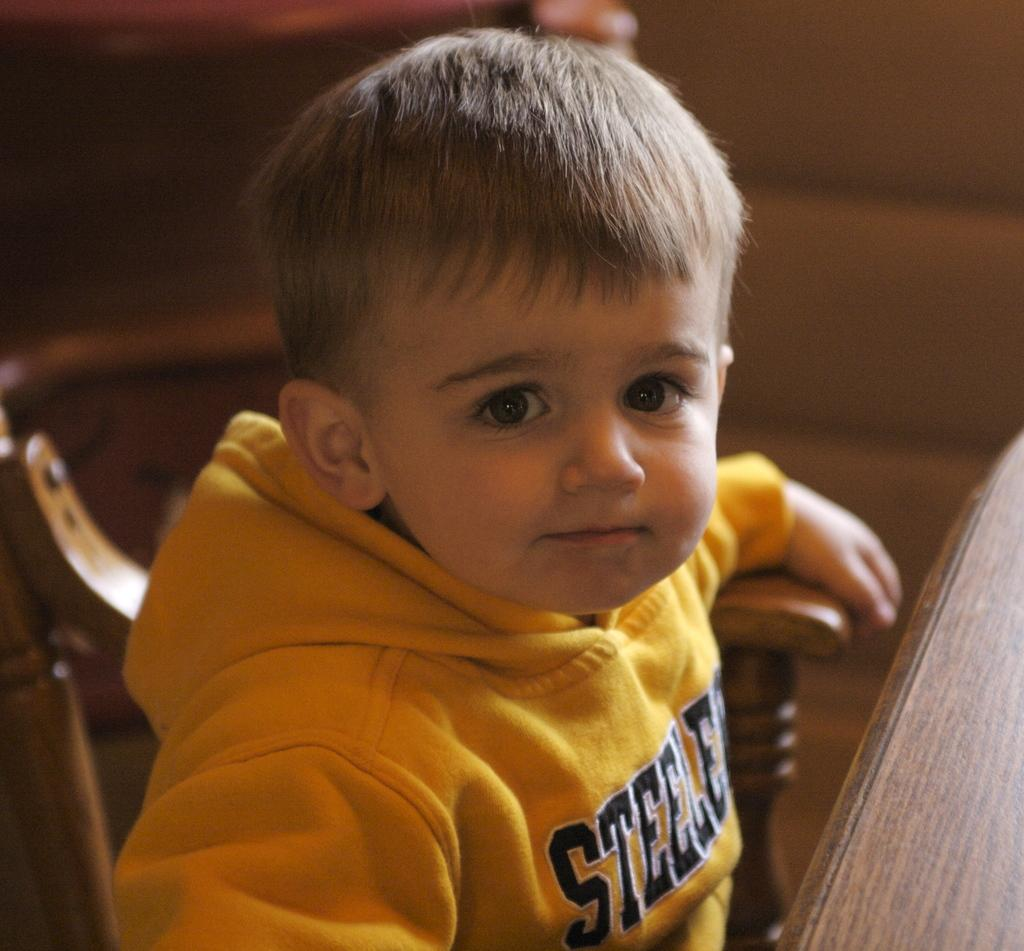What is the main subject of the image? The main subject of the image is a kid. What is the kid wearing in the image? The kid is wearing a yellow jacket in the image. What is the kid doing in the image? The kid is sitting on a chair in the image. What other piece of furniture is present in the image? There is a table in the image. What type of roof can be seen on the chicken in the image? There is no chicken present in the image, and therefore no roof can be seen on it. 